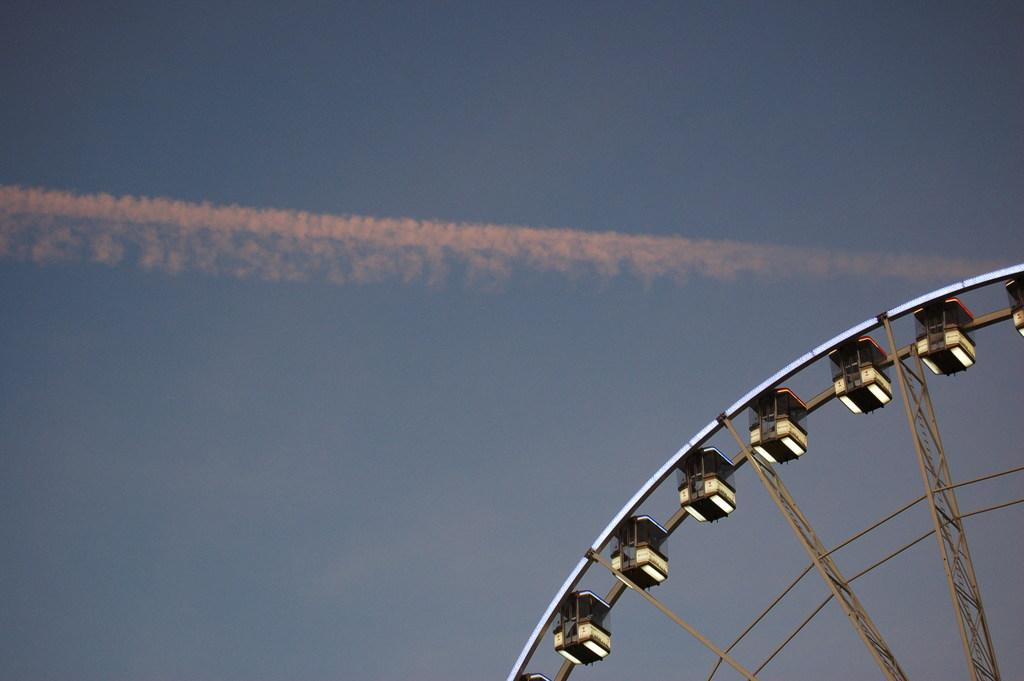What is the main structure located on the right side of the image? There is a giant wheel on the right side of the image. What is visible in the remaining part of the image? The sky is visible in the remaining part of the image. What can be seen in the middle of the image? There is smoke in the middle of the image. What type of fruit is being worked on by the carpenter in the image? There is no fruit or carpenter present in the image. 